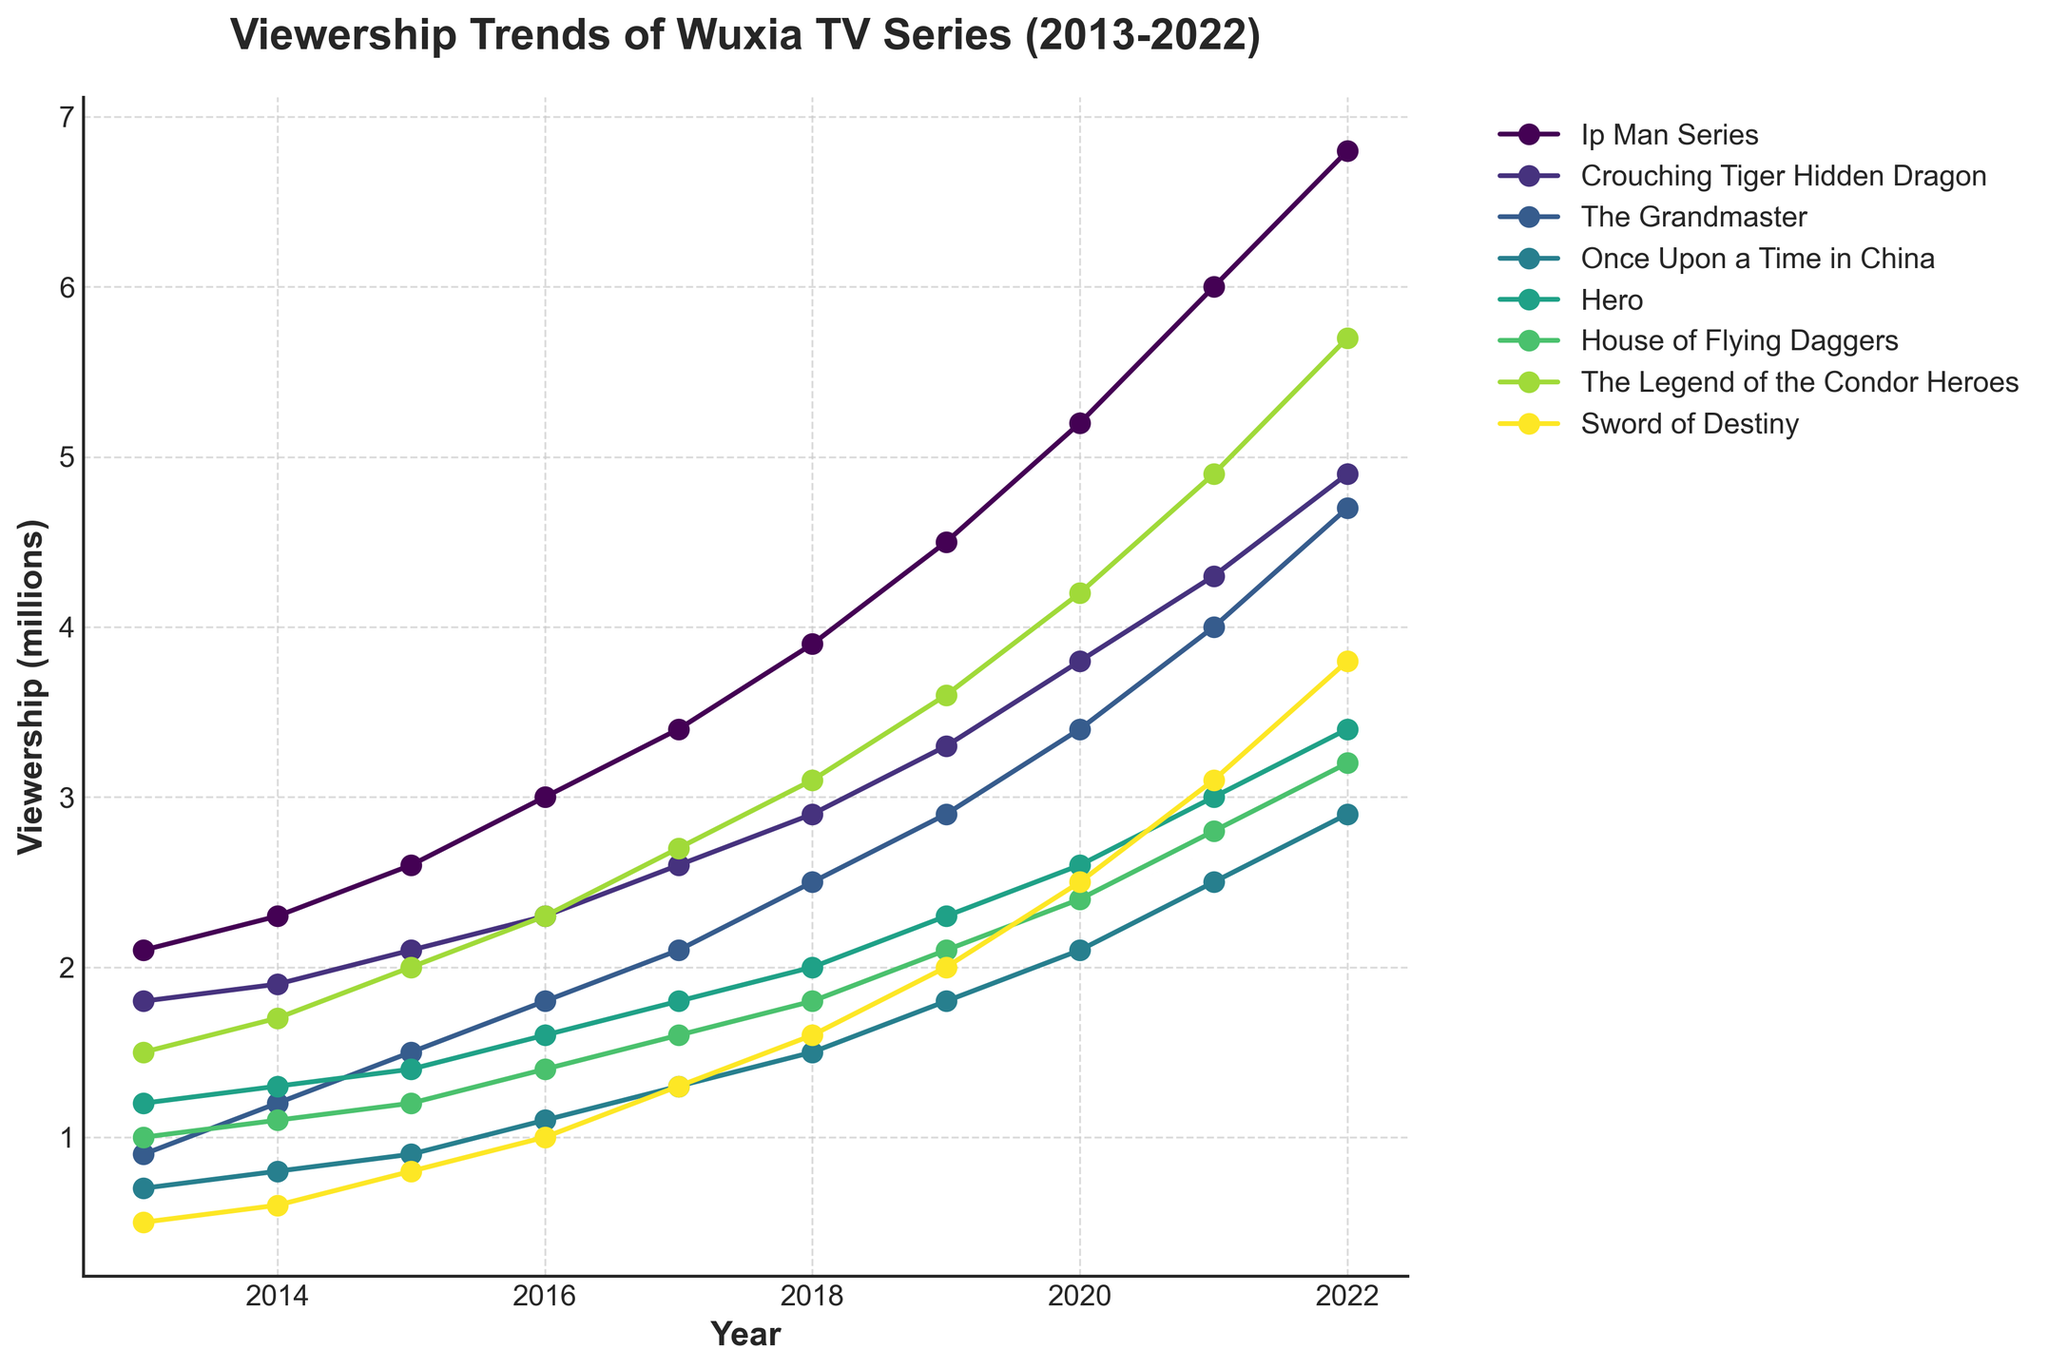What series saw the highest increase in viewership from 2013 to 2022? To determine the series with the highest increase in viewership, subtract the viewership in 2013 from the viewership in 2022 for each series: Ip Man Series (6.8 - 2.1 = 4.7), Crouching Tiger Hidden Dragon (4.9 - 1.8 = 3.1), The Grandmaster (4.7 - 0.9 = 3.8), Once Upon a Time in China (2.9 - 0.7 = 2.2), Hero (3.4 - 1.2 = 2.2), House of Flying Daggers (3.2 - 1.0 = 2.2), The Legend of the Condor Heroes (5.7 - 1.5 = 4.2), Sword of Destiny (3.8 - 0.5 = 3.3). Ip Man Series has the highest increase of 4.7 million.
Answer: Ip Man Series Which two series had equal viewership in any given year? Compare the viewership values across all years for any pairs of series. The Legend of the Condor Heroes and The Grandmaster had equal viewership in 2015, both at 1.5 million.
Answer: The Legend of the Condor Heroes and The Grandmaster By how much did the viewership of Sword of Destiny change from 2013 to 2022? To find the change, subtract the viewership in 2013 from the viewership in 2022 for Sword of Destiny: 3.8 - 0.5 = 3.3 million.
Answer: 3.3 million Which series experienced the highest viewership in 2020? Look at the viewership data for 2020 and identify the maximum value: Ip Man Series had the highest viewership at 5.2 million in 2020.
Answer: Ip Man Series Compare the viewership of House of Flying Daggers and Hero in 2019. Which one was higher and by how much? House of Flying Daggers had a viewership of 2.1 million and Hero had a viewership of 2.3 million in 2019. Subtract the viewership of House of Flying Daggers from Hero: 2.3 - 2.1 = 0.2 million. Hero's viewership was higher by 0.2 million.
Answer: Hero by 0.2 million In what year did The Grandmaster exceed a viewership of 3 million? Check the viewership data for The Grandmaster in each year. In 2021, The Grandmaster exceeded a viewership of 3 million with 4.0 million viewers.
Answer: 2021 Which series had a steady increase in viewership every year from 2013 to 2022? To identify the series with a steady increase, check the viewership values for each series from 2013 to 2022. Ip Man Series showed a steady increase every year.
Answer: Ip Man Series What is the total viewership for Crouching Tiger Hidden Dragon from 2013 to 2022? Sum the viewership values of Crouching Tiger Hidden Dragon from each year: 1.8 + 1.9 + 2.1 + 2.3 + 2.6 + 2.9 + 3.3 + 3.8 + 4.3 + 4.9 = 30.9 million.
Answer: 30.9 million Between 2014 and 2018, which series had the highest average viewership? Calculate the average viewership for each series between 2014 and 2018. Ip Man Series: (2.3 + 2.6 + 3.0 + 3.4 + 3.9)/5 = 3.04, Crouching Tiger Hidden Dragon: (1.9 + 2.1 + 2.3 + 2.6 + 2.9)/5 = 2.36, The Grandmaster: (1.2 + 1.5 + 1.8 + 2.1 + 2.5)/5 = 1.82, Once Upon a Time in China: (0.8 + 0.9 + 1.1 + 1.3 + 1.5)/5 = 1.12, Hero: (1.3 + 1.4 + 1.6 + 1.8 + 2.0)/5 = 1.62, House of Flying Daggers: (1.1 + 1.2 + 1.4 + 1.6 + 1.8)/5 = 1.42, The Legend of the Condor Heroes: (1.7 + 2.0 + 2.3 + 2.7 + 3.1)/5 = 2.36, Sword of Destiny: (0.6 + 0.8 + 1.0 + 1.3 + 1.6)/5 = 1.06. Ip Man Series had the highest average viewership of 3.04 million.
Answer: Ip Man Series 